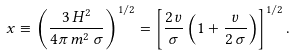Convert formula to latex. <formula><loc_0><loc_0><loc_500><loc_500>x \equiv \left ( \frac { 3 \, H ^ { 2 } } { 4 \pi \, m ^ { 2 } \, \sigma } \right ) ^ { 1 / 2 } = \left [ \frac { 2 \, v } { \sigma } \left ( 1 + \frac { v } { 2 \, \sigma } \right ) \right ] ^ { 1 / 2 } .</formula> 